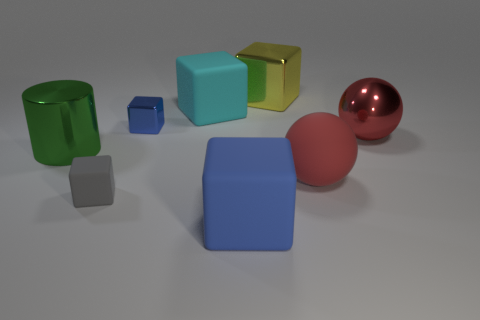Subtract all cyan cubes. How many cubes are left? 4 Subtract all gray blocks. How many blocks are left? 4 Subtract all brown cubes. Subtract all purple spheres. How many cubes are left? 5 Add 2 brown things. How many objects exist? 10 Subtract all cubes. How many objects are left? 3 Add 3 large cyan rubber objects. How many large cyan rubber objects are left? 4 Add 2 yellow metal cubes. How many yellow metal cubes exist? 3 Subtract 0 blue spheres. How many objects are left? 8 Subtract all tiny shiny things. Subtract all yellow things. How many objects are left? 6 